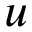<formula> <loc_0><loc_0><loc_500><loc_500>u</formula> 